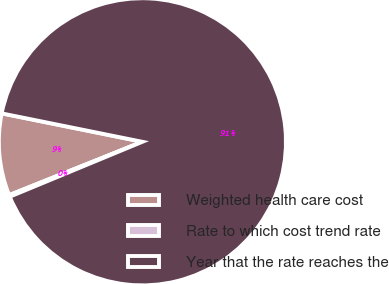<chart> <loc_0><loc_0><loc_500><loc_500><pie_chart><fcel>Weighted health care cost<fcel>Rate to which cost trend rate<fcel>Year that the rate reaches the<nl><fcel>9.23%<fcel>0.19%<fcel>90.58%<nl></chart> 